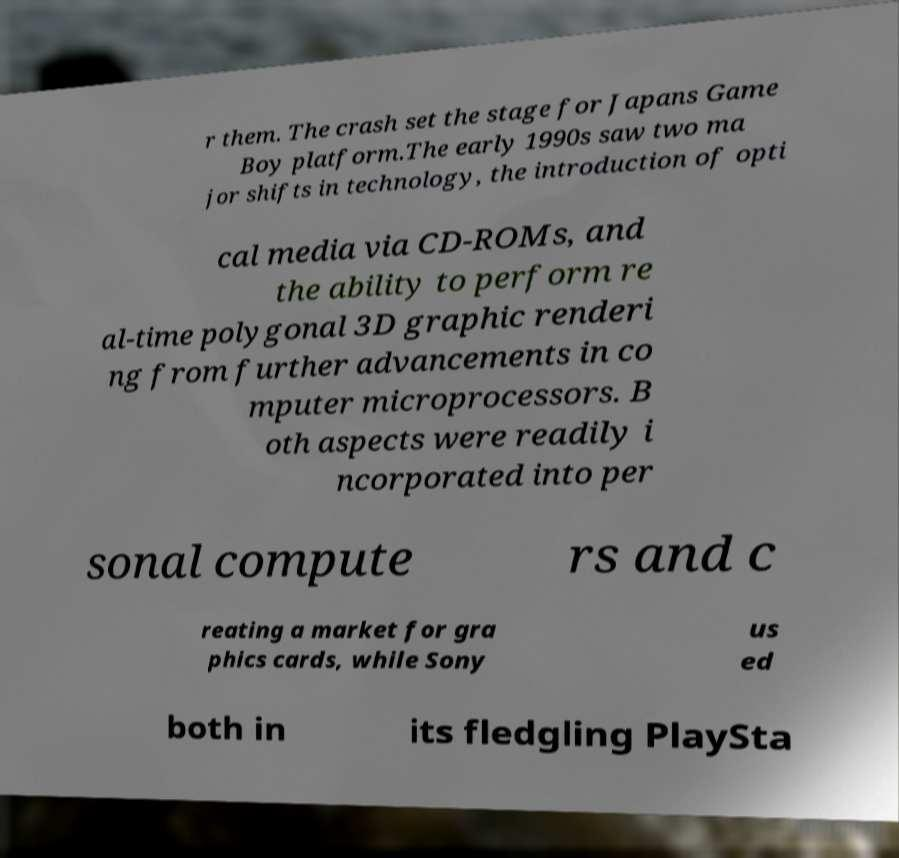There's text embedded in this image that I need extracted. Can you transcribe it verbatim? r them. The crash set the stage for Japans Game Boy platform.The early 1990s saw two ma jor shifts in technology, the introduction of opti cal media via CD-ROMs, and the ability to perform re al-time polygonal 3D graphic renderi ng from further advancements in co mputer microprocessors. B oth aspects were readily i ncorporated into per sonal compute rs and c reating a market for gra phics cards, while Sony us ed both in its fledgling PlaySta 